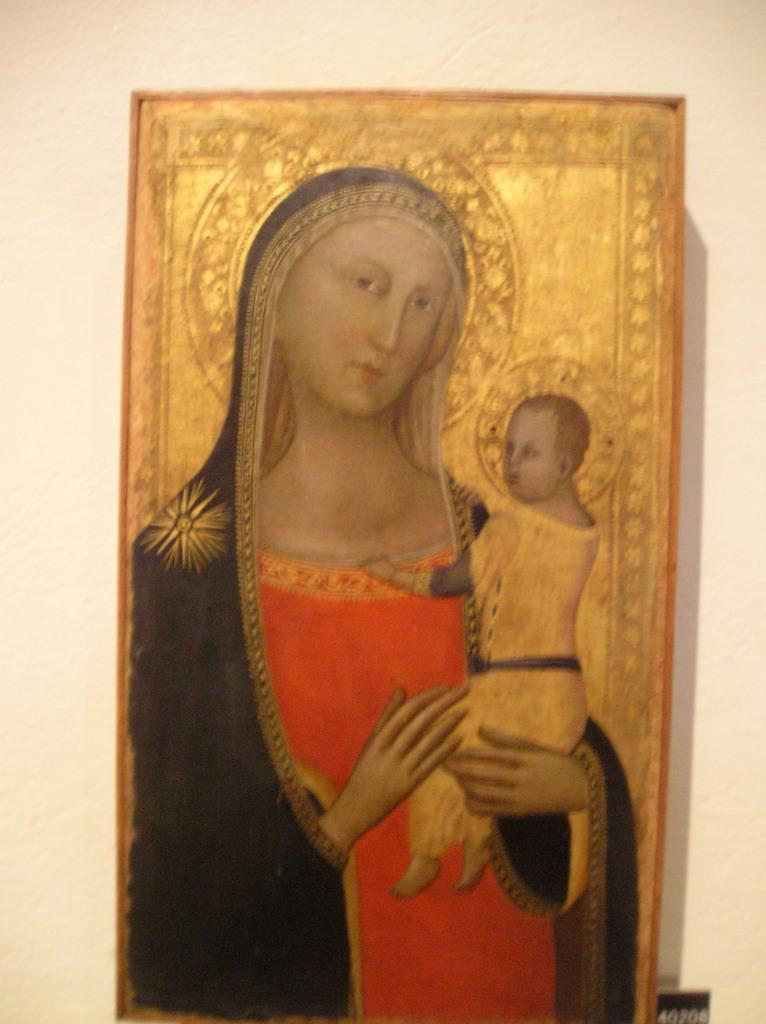What is the main subject of the image? There is a depiction of a lady in the center of the image. What can be seen in the background of the image? There is a wall in the background of the image. What type of bean is being used as a prop in the image? There is no bean present in the image. 